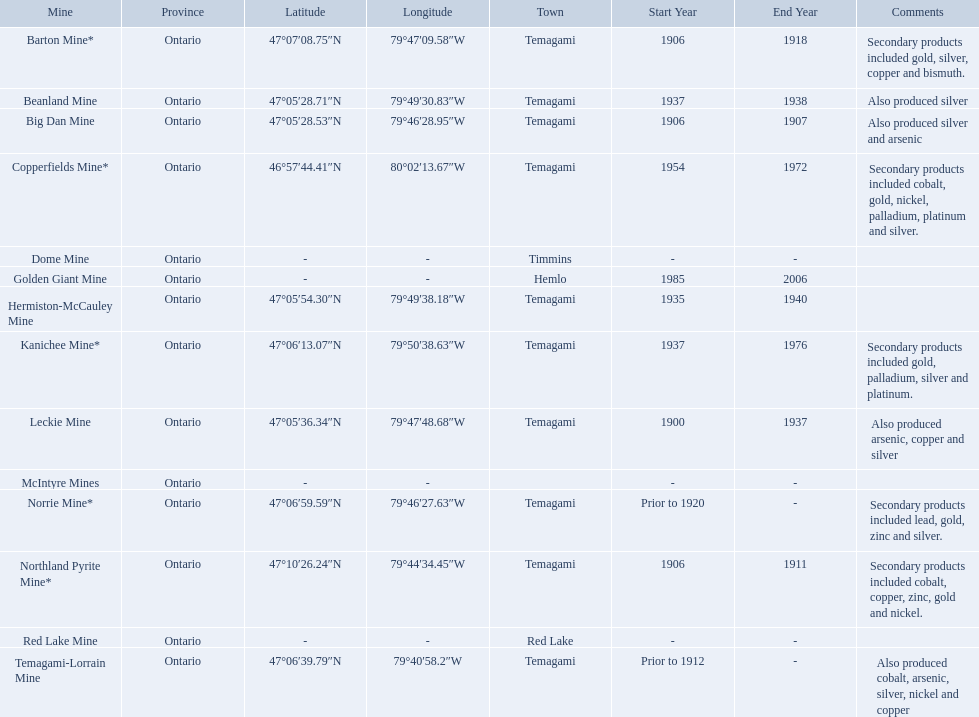What years was the golden giant mine open for? 1985-2006. What years was the beanland mine open? 1937-1938. Which of these two mines was open longer? Golden Giant Mine. 